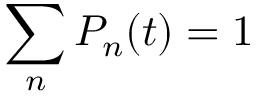Convert formula to latex. <formula><loc_0><loc_0><loc_500><loc_500>\sum _ { n } P _ { n } ( t ) = 1</formula> 